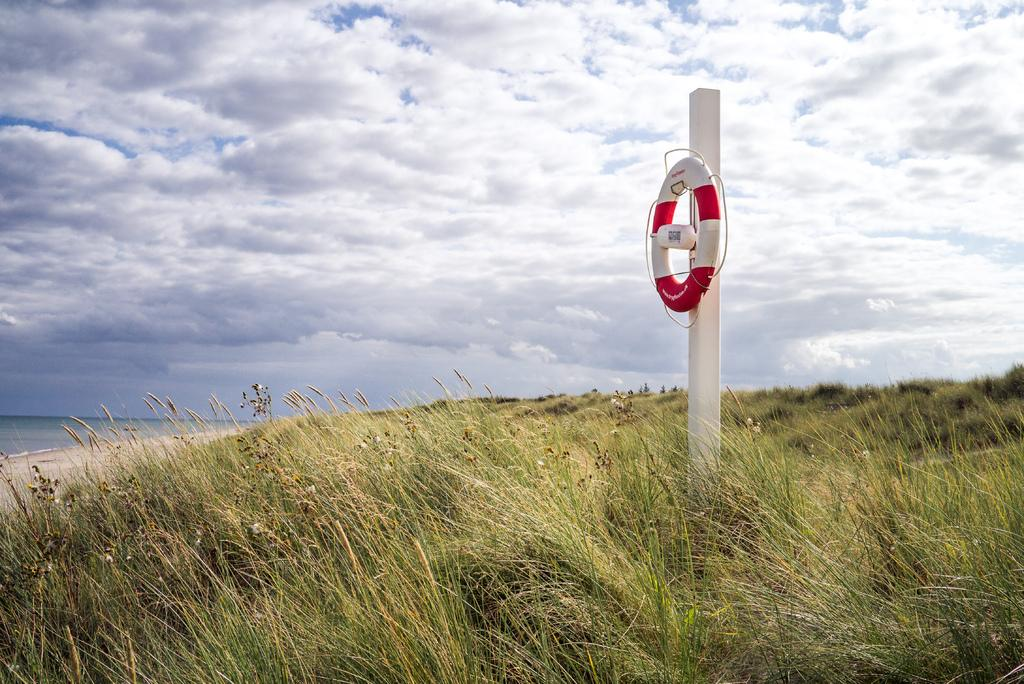What is the main object in the image? There is a pole in the image. What is attached to the pole? A swim ring is attached to the pole. What type of environment is visible in the background of the image? There is grass and the sky visible in the background of the image. What type of club is being used to hit the insect in the image? There is no club or insect present in the image. 